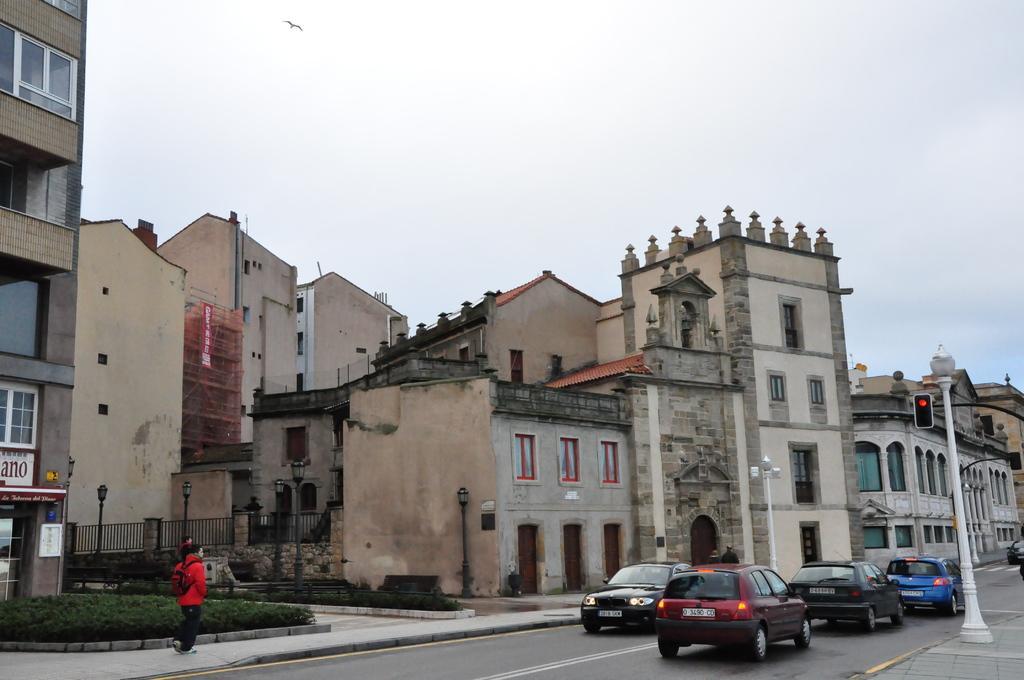Could you give a brief overview of what you see in this image? In the center of the image buildings are there. On the right side of the image we can see the poles, traffic light, cars, road are present. On the left side of the image we can see a person is walking on a road and plants are present. At the top of the image sky and a bird are present. At the bottom of the image road is there. 